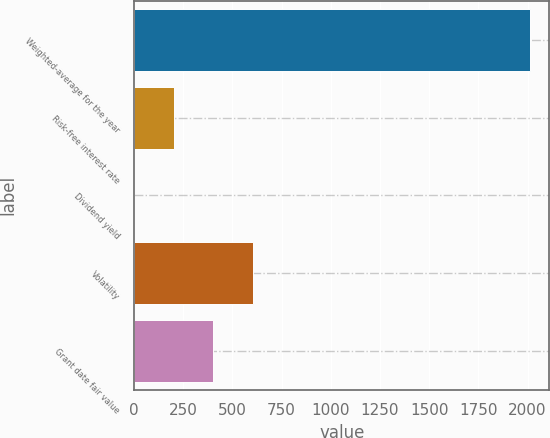Convert chart to OTSL. <chart><loc_0><loc_0><loc_500><loc_500><bar_chart><fcel>Weighted-average for the year<fcel>Risk-free interest rate<fcel>Dividend yield<fcel>Volatility<fcel>Grant date fair value<nl><fcel>2010<fcel>201.63<fcel>0.7<fcel>603.49<fcel>402.56<nl></chart> 